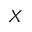<formula> <loc_0><loc_0><loc_500><loc_500>X</formula> 